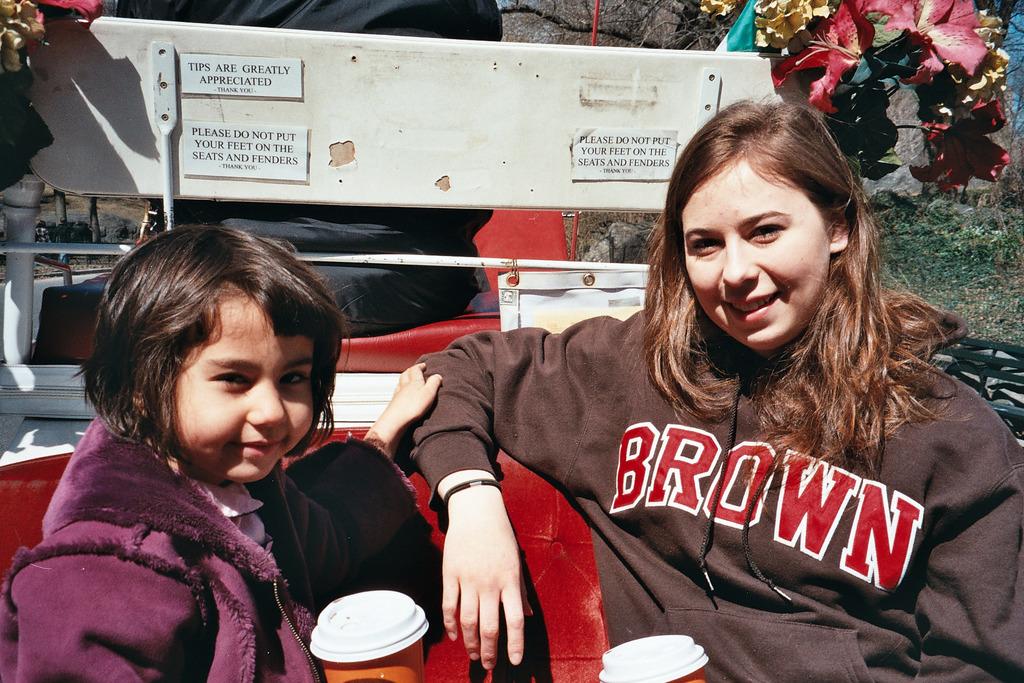What school does the lady most likely attend?
Keep it short and to the point. Brown. What is appreciated?
Provide a short and direct response. Tips. 